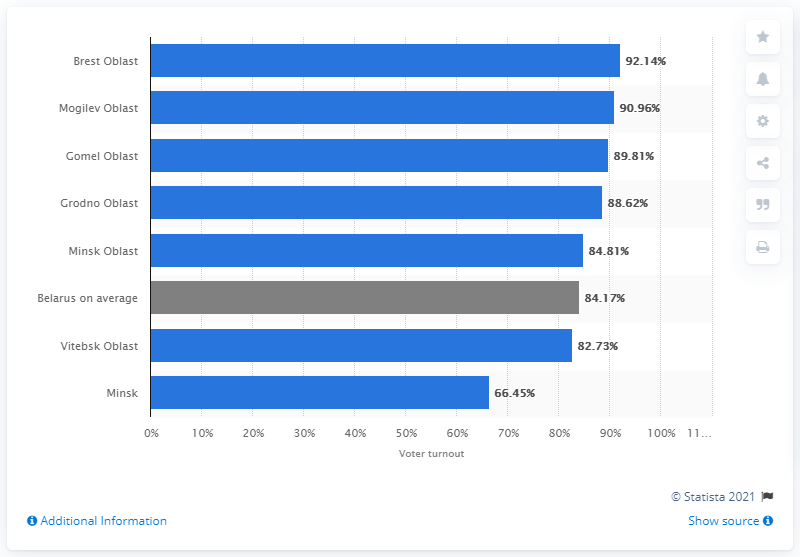Specify some key components in this picture. The presidential election had the lowest turnout in Minsk. 